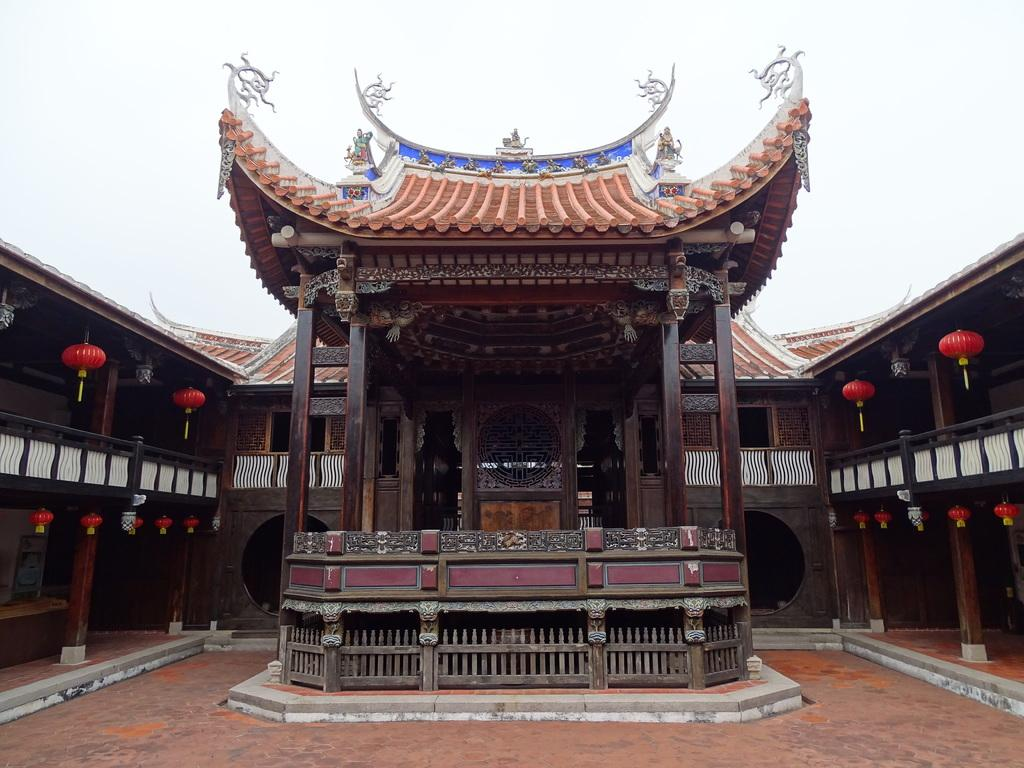What type of structures can be seen in the image? There are houses in the image. What architectural features are present in the image? There are wooden pillars in the image. What can be seen beneath the structures and pillars? The ground is visible in the image. What color is present on some objects in the image? There are red colored objects in the image. What is visible above the houses and pillars? The sky is visible in the image. Can you tell me how many boys are playing the guitar in the image? There are no boys or guitars present in the image. What type of butter is being used to paint the red objects in the image? There is no butter present in the image, and the red objects are not being painted. 